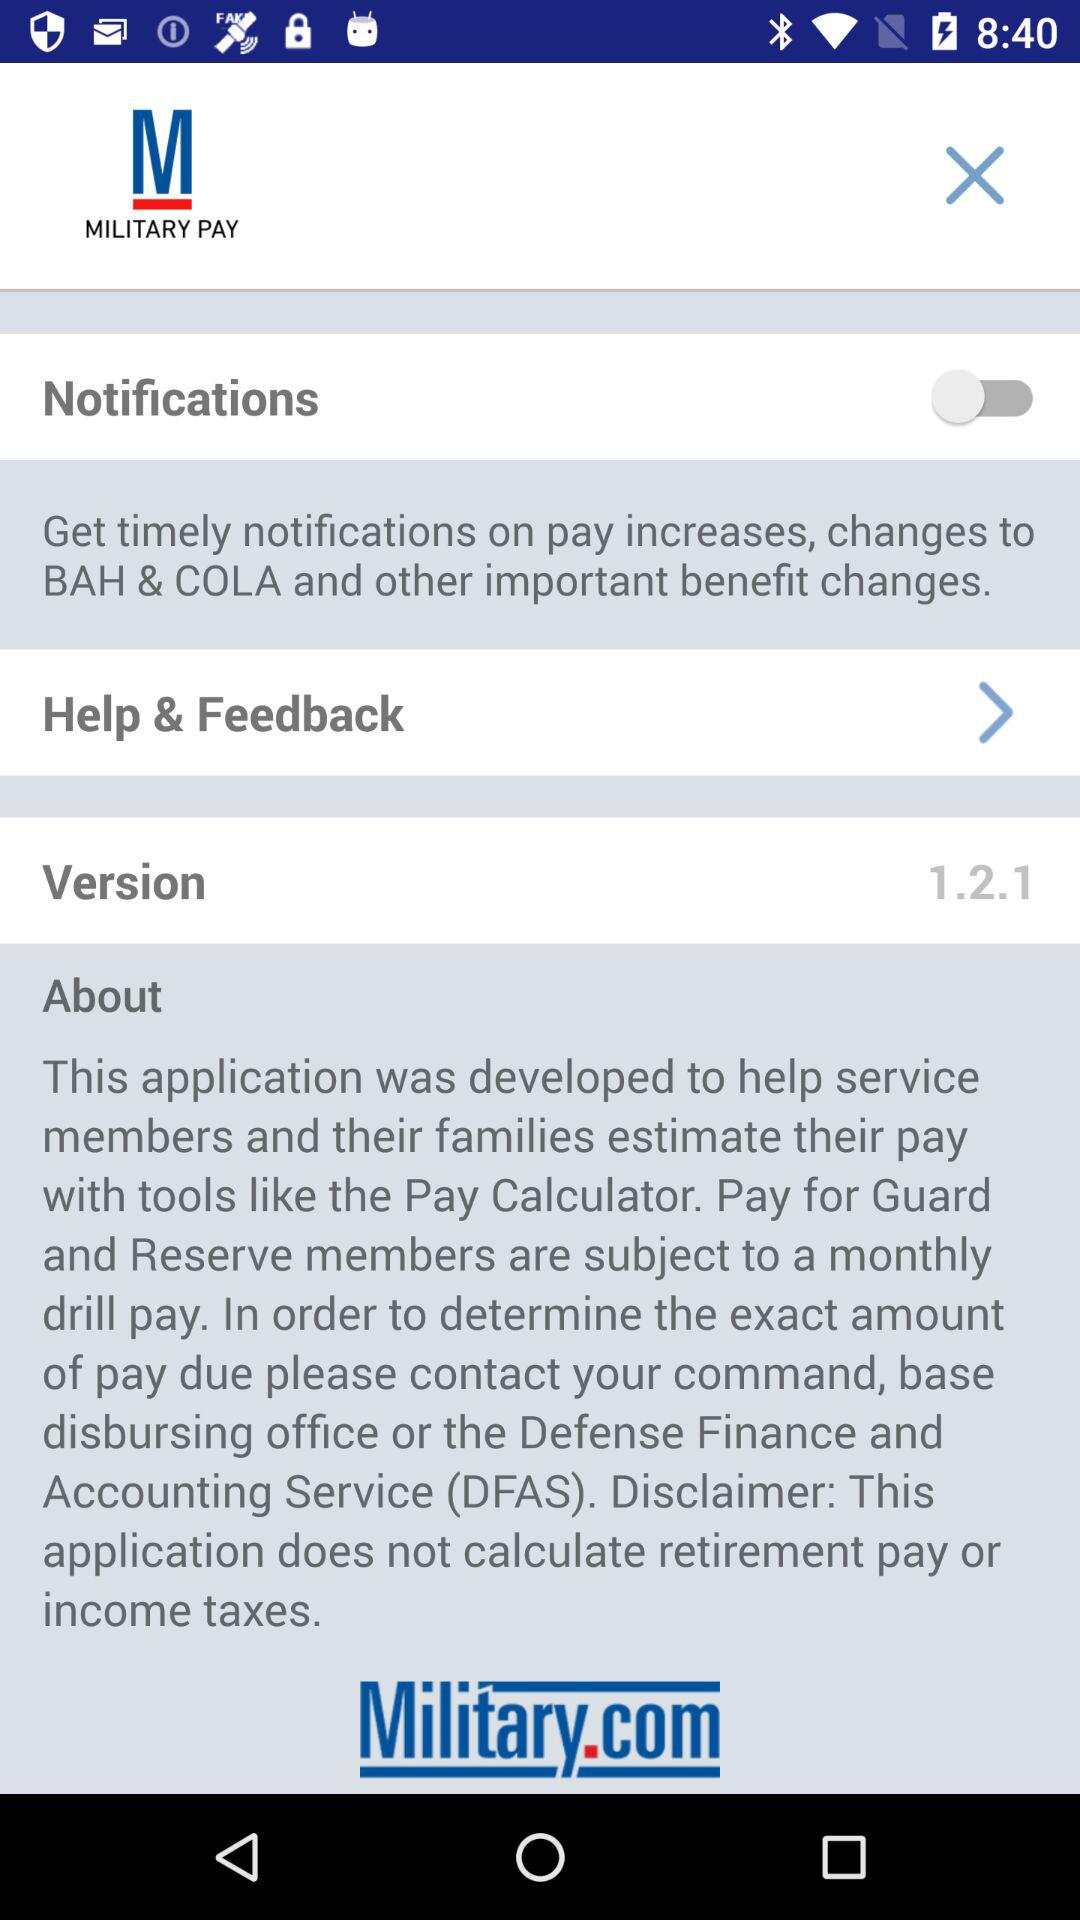What is the application name? The application name is "MILITARY PAY". 